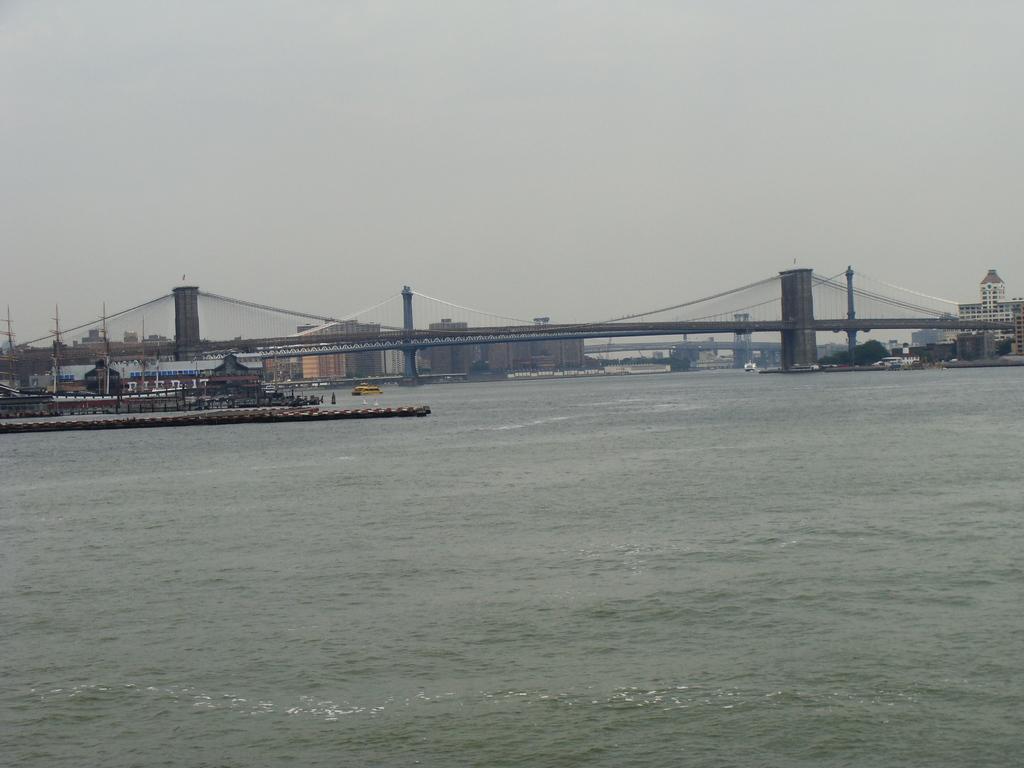How would you summarize this image in a sentence or two? In this image, we can see some boats sailing in the water. We can also see the bridge. There are a few buildings. We can see the ground with some objects. We can also see the sky. We can see some poles. 